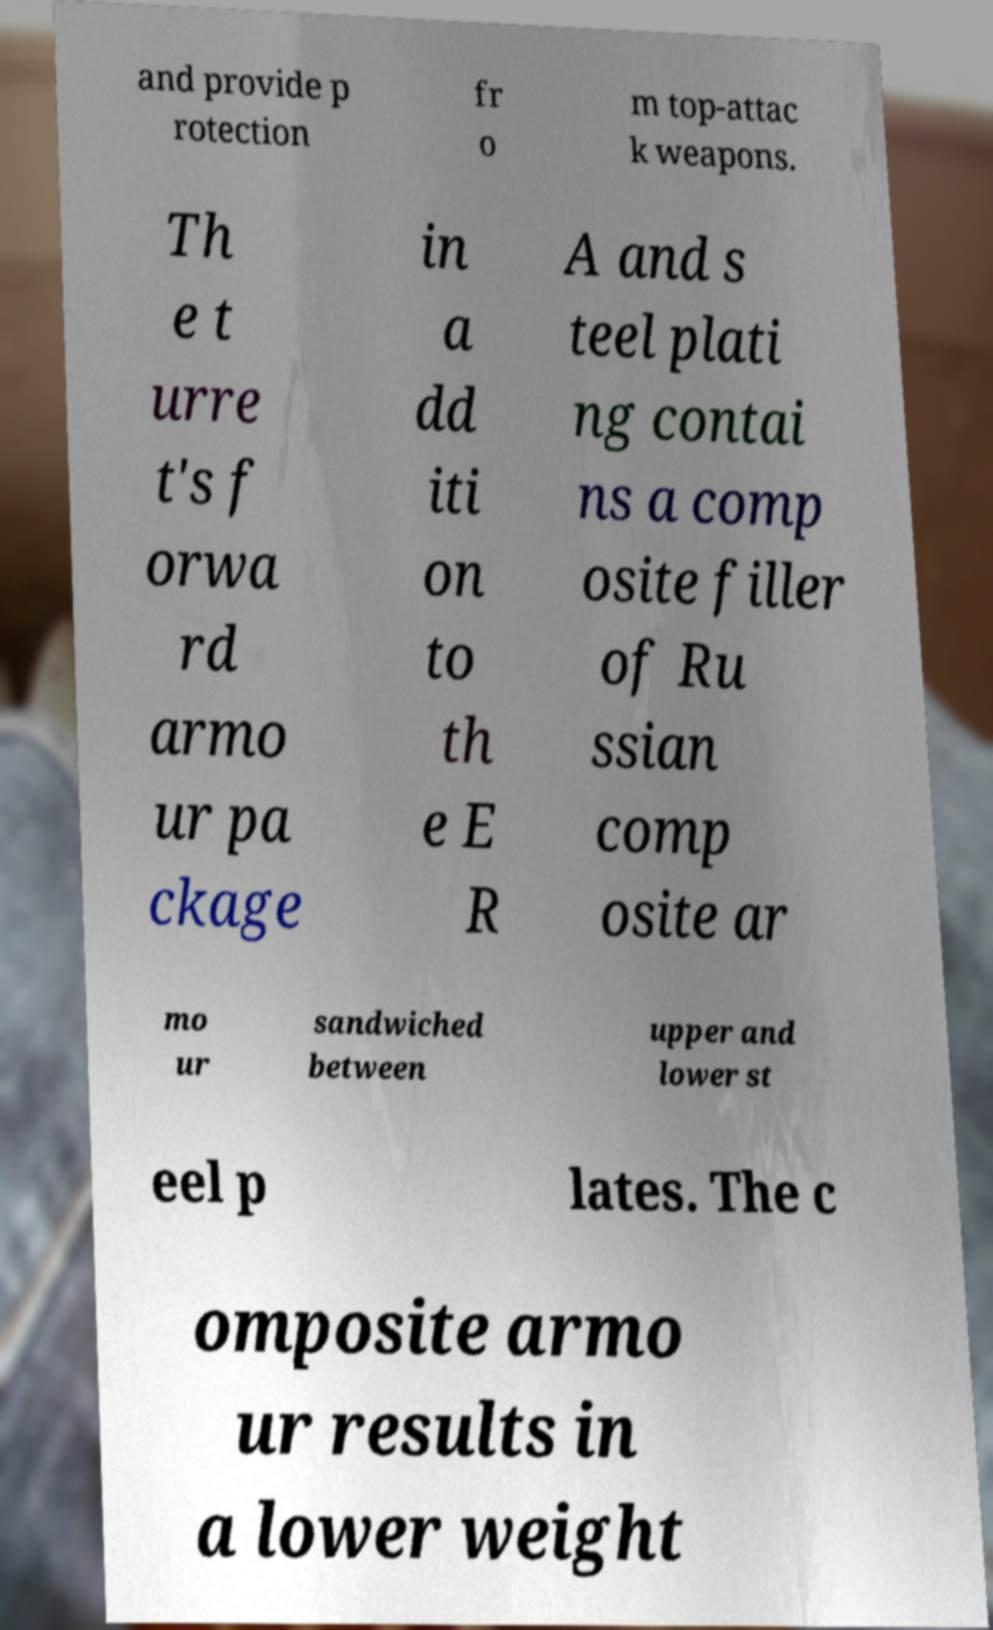Can you accurately transcribe the text from the provided image for me? and provide p rotection fr o m top-attac k weapons. Th e t urre t's f orwa rd armo ur pa ckage in a dd iti on to th e E R A and s teel plati ng contai ns a comp osite filler of Ru ssian comp osite ar mo ur sandwiched between upper and lower st eel p lates. The c omposite armo ur results in a lower weight 